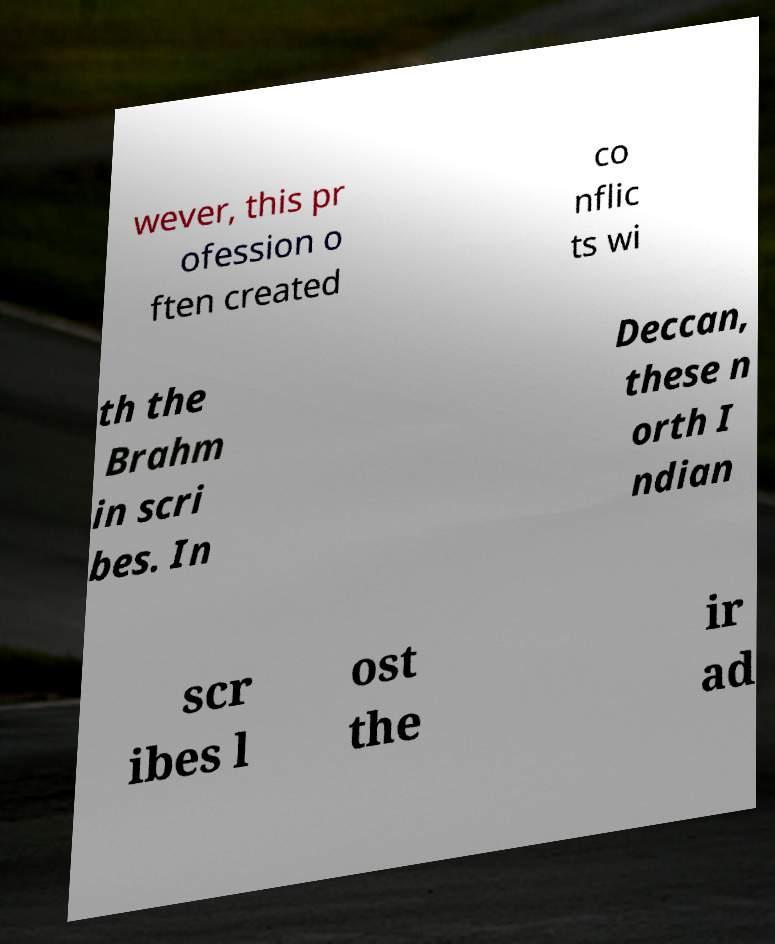For documentation purposes, I need the text within this image transcribed. Could you provide that? wever, this pr ofession o ften created co nflic ts wi th the Brahm in scri bes. In Deccan, these n orth I ndian scr ibes l ost the ir ad 